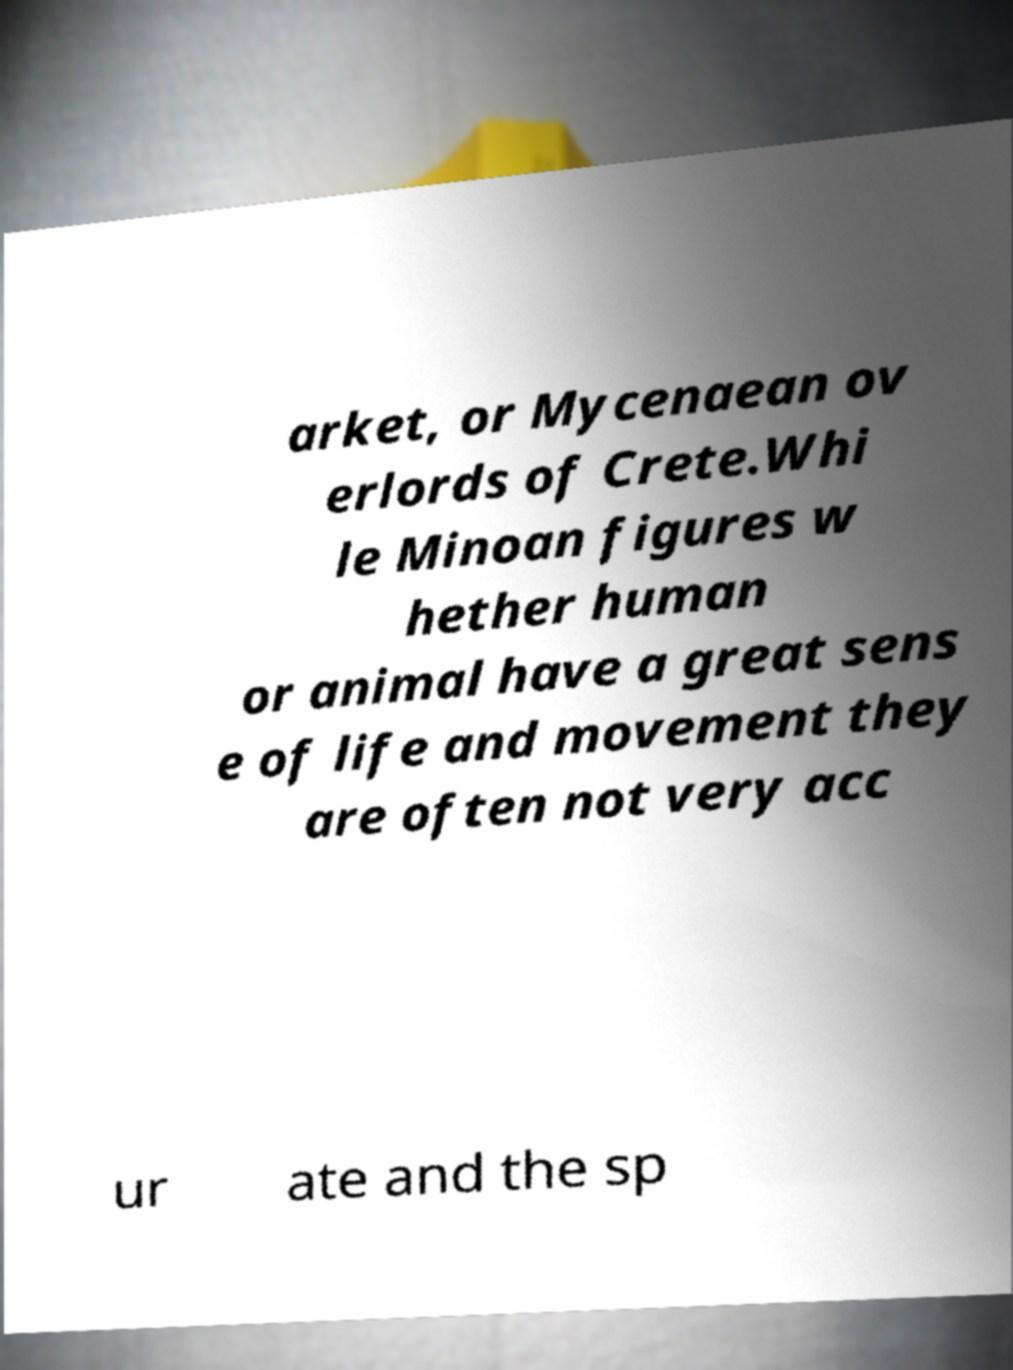For documentation purposes, I need the text within this image transcribed. Could you provide that? arket, or Mycenaean ov erlords of Crete.Whi le Minoan figures w hether human or animal have a great sens e of life and movement they are often not very acc ur ate and the sp 